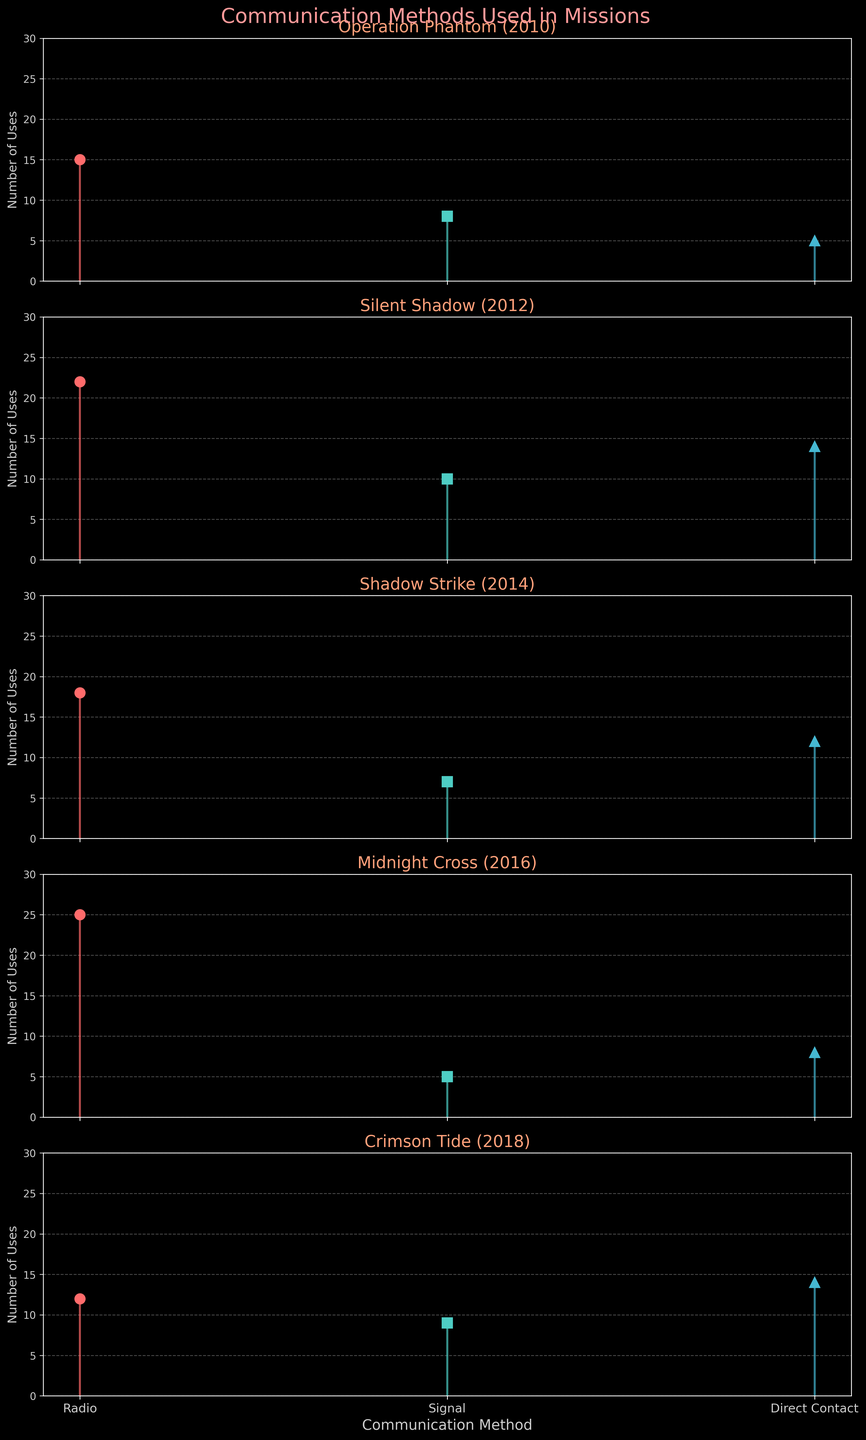Which mission had the highest number of uses for Radio communication? The subplot for each mission represents the data points. Looking at the values in the Radio communication stem plots for all missions, Midnight Cross in 2016 had the highest usage.
Answer: Midnight Cross Which communication method was least used in Operation Phantom? Within the Operation Phantom subplot, the stem plot shows Direct Contact with 5 uses, which is the lowest compared to Radio (15 uses) and Signal (8 uses).
Answer: Direct Contact In which mission did Direct Contact communications exceed 10 uses? By examining the stem plots for Direct Contact communication method across missions, Silent Shadow (14 uses), Shadow Strike (12 uses), and Crimson Tide (14 uses) all show values exceeding 10.
Answer: Silent Shadow, Shadow Strike, Crimson Tide What is the total number of uses for Signal communication across all missions? The uses for Signal communication in each mission are: Operation Phantom (8), Silent Shadow (10), Shadow Strike (7), Midnight Cross (5), and Crimson Tide (9). Summing these up: 8 + 10 + 7 + 5 + 9 = 39.
Answer: 39 What is the average number of uses for Radio communication across all missions? The Radio communication uses in each mission are: Operation Phantom (15), Silent Shadow (22), Shadow Strike (18), Midnight Cross (25), Crimson Tide (12). Calculating the average: (15 + 22 + 18 + 25 + 12) / 5 = 18.4.
Answer: 18.4 Which mission had the smallest difference between the highest and lowest communication method usages? Subtracting the lowest usage from the highest for each mission: Operation Phantom (15-5=10), Silent Shadow (22-10=12), Shadow Strike (18-7=11), Midnight Cross (25-5=20), Crimson Tide (14-9=5). The smallest difference is in Crimson Tide.
Answer: Crimson Tide How does the use of Direct Contact in Silent Shadow compare to the rest of the missions? Direct Contact has the following uses in each mission: Operation Phantom (5), Silent Shadow (14), Shadow Strike (12), Midnight Cross (8), Crimson Tide (14). Silent Shadow and Crimson Tide both have the highest usage (14), while other missions have lower values.
Answer: Highest along with Crimson Tide What is the second most used communication method in Shadow Strike? Evaluating the stem plots for Shadow Strike, Radio is the most used (18). Direct Contact (12) is higher than Signal (7), making it the second most used.
Answer: Direct Contact 